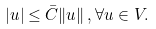Convert formula to latex. <formula><loc_0><loc_0><loc_500><loc_500>| u | \leq \bar { C } \| u \| \, , \forall u \in V .</formula> 